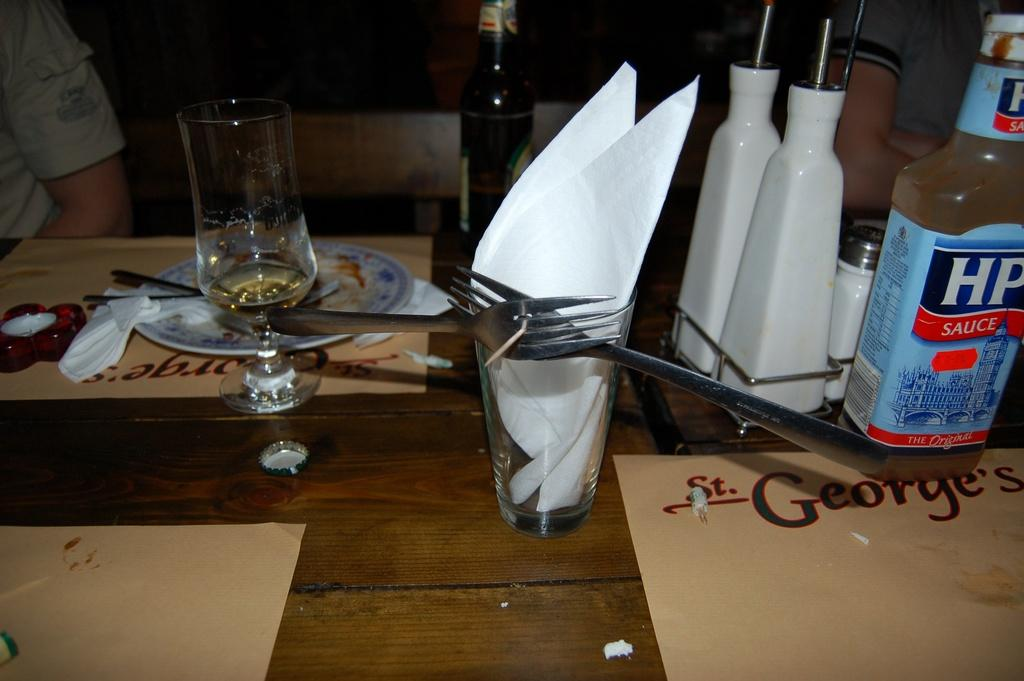What piece of furniture is present in the image? There is a table in the image. What utensils can be seen on the table? There are forks on the table. What type of dishware is present on the table? There are glasses, plates, and bottles on the table. What type of meat is being served on the table in the image? There is no meat present in the image; the table only contains forks, glasses, plates, and bottles. 